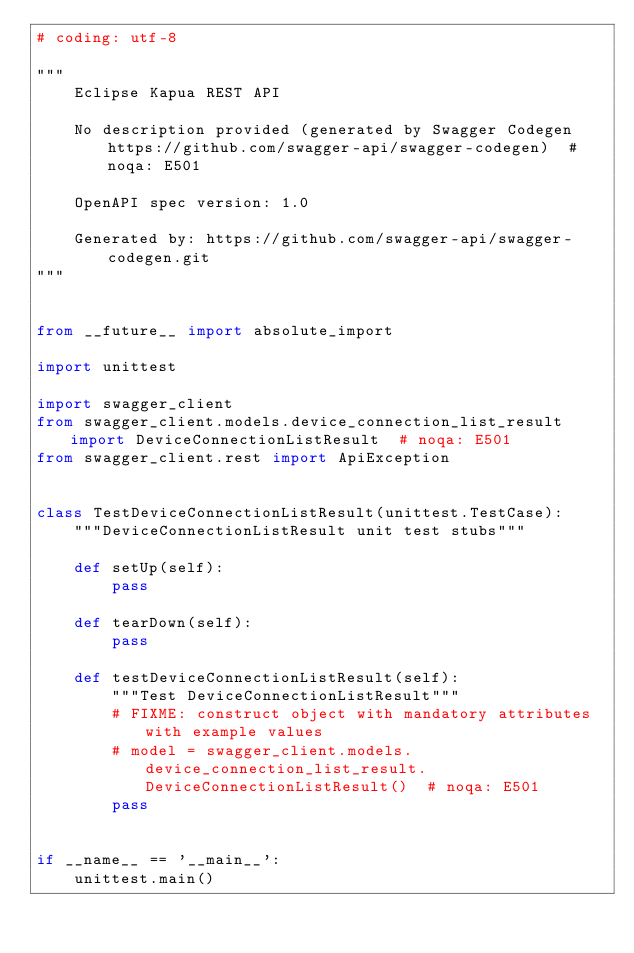Convert code to text. <code><loc_0><loc_0><loc_500><loc_500><_Python_># coding: utf-8

"""
    Eclipse Kapua REST API

    No description provided (generated by Swagger Codegen https://github.com/swagger-api/swagger-codegen)  # noqa: E501

    OpenAPI spec version: 1.0
    
    Generated by: https://github.com/swagger-api/swagger-codegen.git
"""


from __future__ import absolute_import

import unittest

import swagger_client
from swagger_client.models.device_connection_list_result import DeviceConnectionListResult  # noqa: E501
from swagger_client.rest import ApiException


class TestDeviceConnectionListResult(unittest.TestCase):
    """DeviceConnectionListResult unit test stubs"""

    def setUp(self):
        pass

    def tearDown(self):
        pass

    def testDeviceConnectionListResult(self):
        """Test DeviceConnectionListResult"""
        # FIXME: construct object with mandatory attributes with example values
        # model = swagger_client.models.device_connection_list_result.DeviceConnectionListResult()  # noqa: E501
        pass


if __name__ == '__main__':
    unittest.main()
</code> 